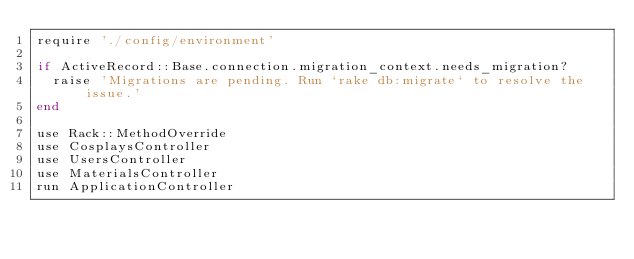Convert code to text. <code><loc_0><loc_0><loc_500><loc_500><_Ruby_>require './config/environment'

if ActiveRecord::Base.connection.migration_context.needs_migration?
  raise 'Migrations are pending. Run `rake db:migrate` to resolve the issue.'
end

use Rack::MethodOverride
use CosplaysController
use UsersController
use MaterialsController
run ApplicationController</code> 